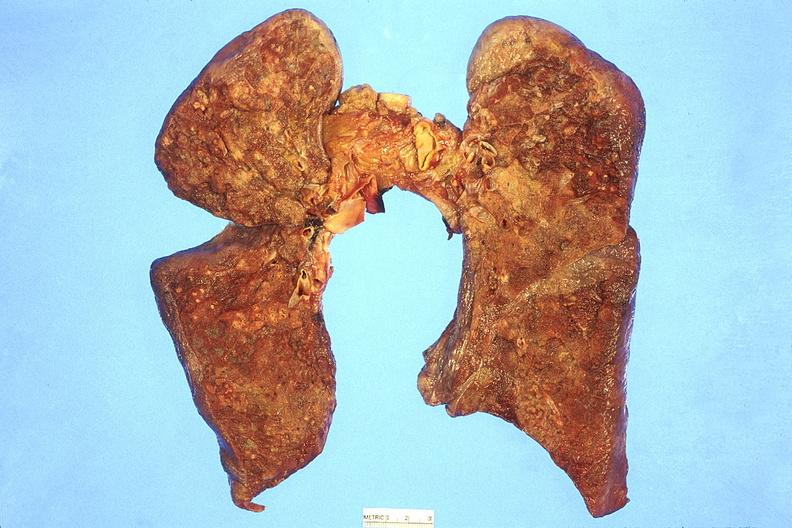what is present?
Answer the question using a single word or phrase. Respiratory 